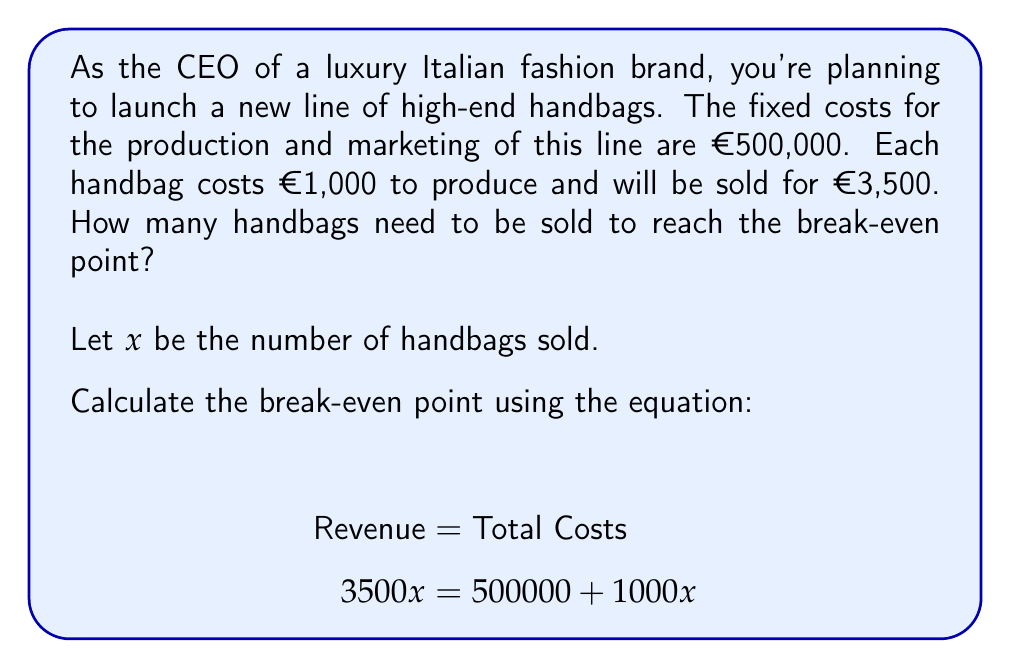Give your solution to this math problem. To solve this problem, we'll use the break-even analysis formula:

$$\text{Revenue} = \text{Fixed Costs} + \text{Variable Costs}$$

Given:
- Fixed Costs (FC) = €500,000
- Price per unit (P) = €3,500
- Variable Cost per unit (VC) = €1,000
- Let $x$ be the number of handbags sold

Step 1: Set up the equation
$$3500x = 500000 + 1000x$$

Step 2: Subtract 1000x from both sides
$$2500x = 500000$$

Step 3: Divide both sides by 2500
$$x = \frac{500000}{2500} = 200$$

Therefore, the break-even point is reached when 200 handbags are sold.

To verify:
Revenue at break-even: $200 \times €3,500 = €700,000$
Total Costs at break-even: $€500,000 + (200 \times €1,000) = €700,000$

As Revenue equals Total Costs, this confirms the break-even point.
Answer: The break-even point is reached when 200 handbags are sold. 